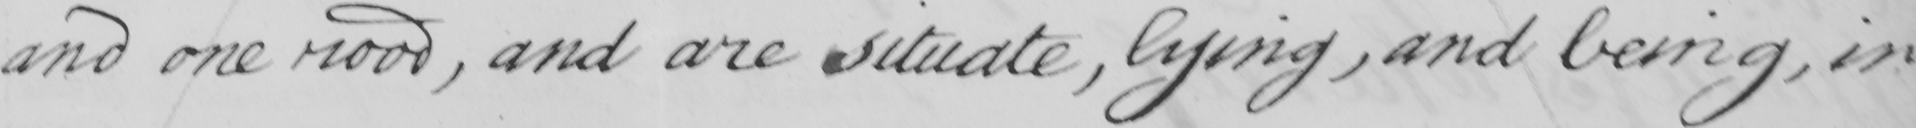Please transcribe the handwritten text in this image. and one rood , and are situate , lying , and being , in 